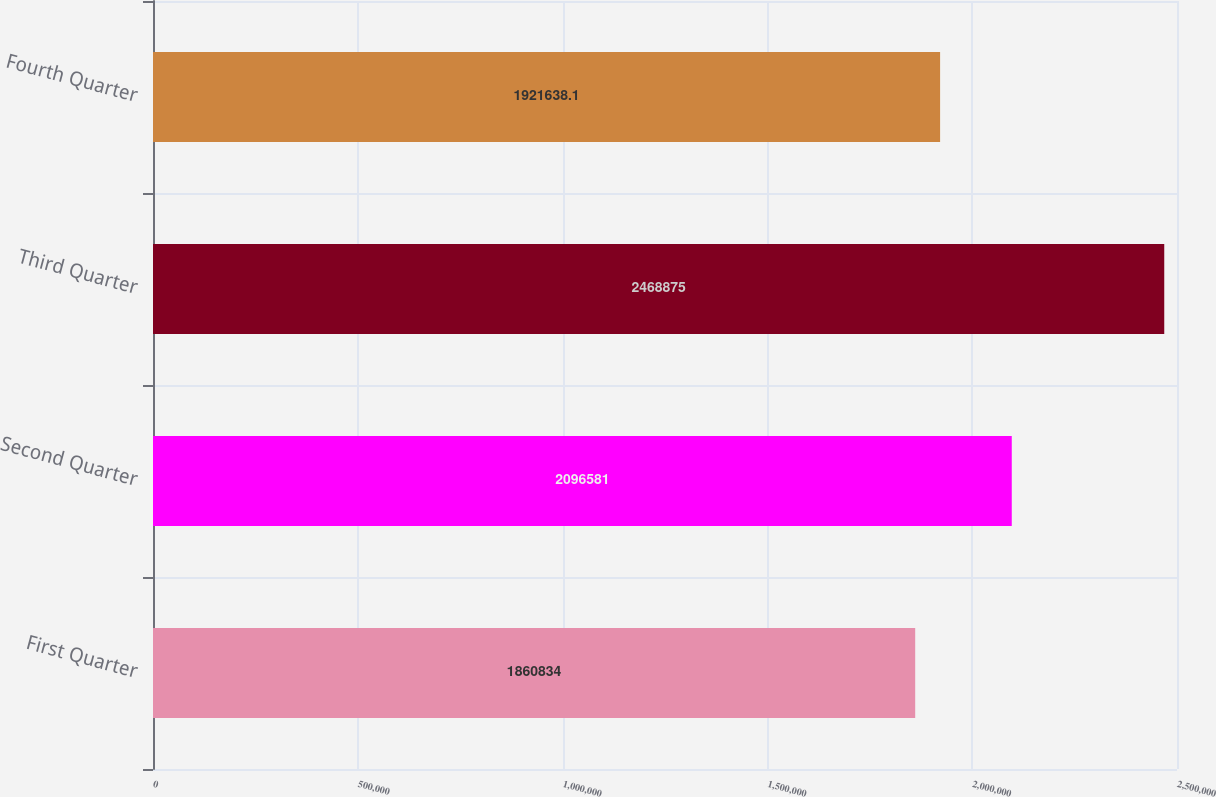Convert chart to OTSL. <chart><loc_0><loc_0><loc_500><loc_500><bar_chart><fcel>First Quarter<fcel>Second Quarter<fcel>Third Quarter<fcel>Fourth Quarter<nl><fcel>1.86083e+06<fcel>2.09658e+06<fcel>2.46888e+06<fcel>1.92164e+06<nl></chart> 